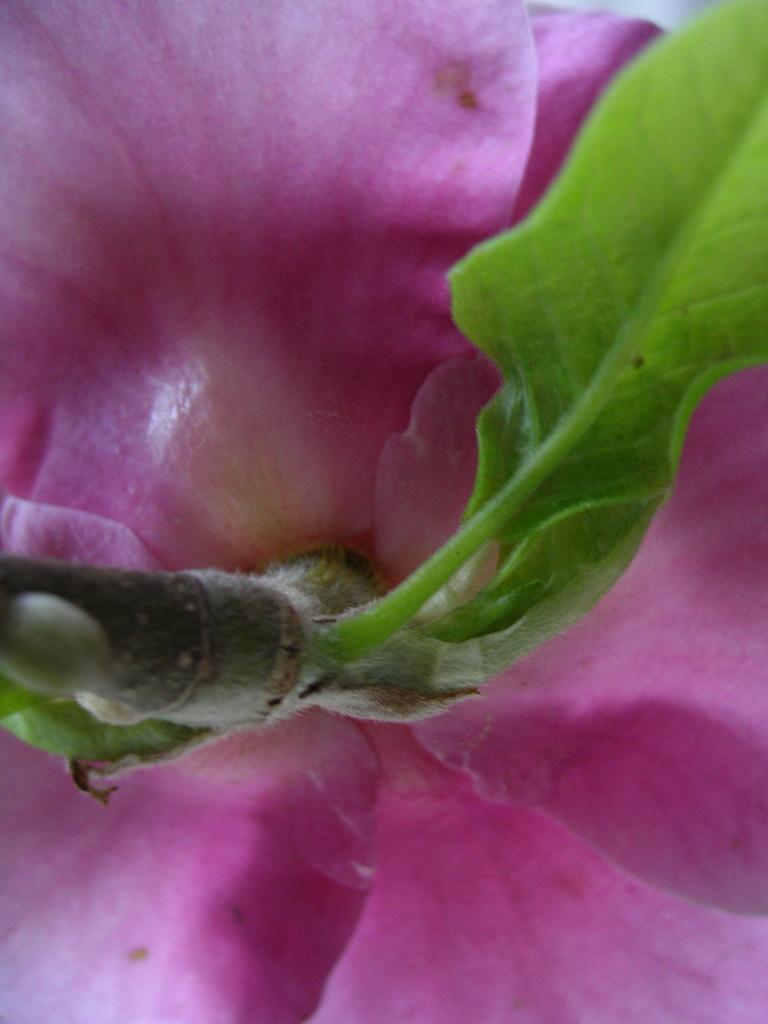In one or two sentences, can you explain what this image depicts? Here in this picture we can see a closeup view of a flower, as we can see its petals and leaf present. 